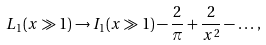<formula> <loc_0><loc_0><loc_500><loc_500>L _ { 1 } ( x \gg 1 ) \rightarrow I _ { 1 } ( x \gg 1 ) - \frac { 2 } { \pi } + \frac { 2 } { x ^ { 2 } } - \dots \, ,</formula> 